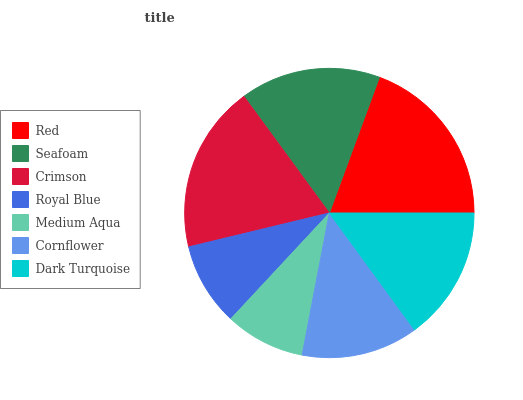Is Medium Aqua the minimum?
Answer yes or no. Yes. Is Red the maximum?
Answer yes or no. Yes. Is Seafoam the minimum?
Answer yes or no. No. Is Seafoam the maximum?
Answer yes or no. No. Is Red greater than Seafoam?
Answer yes or no. Yes. Is Seafoam less than Red?
Answer yes or no. Yes. Is Seafoam greater than Red?
Answer yes or no. No. Is Red less than Seafoam?
Answer yes or no. No. Is Dark Turquoise the high median?
Answer yes or no. Yes. Is Dark Turquoise the low median?
Answer yes or no. Yes. Is Seafoam the high median?
Answer yes or no. No. Is Red the low median?
Answer yes or no. No. 